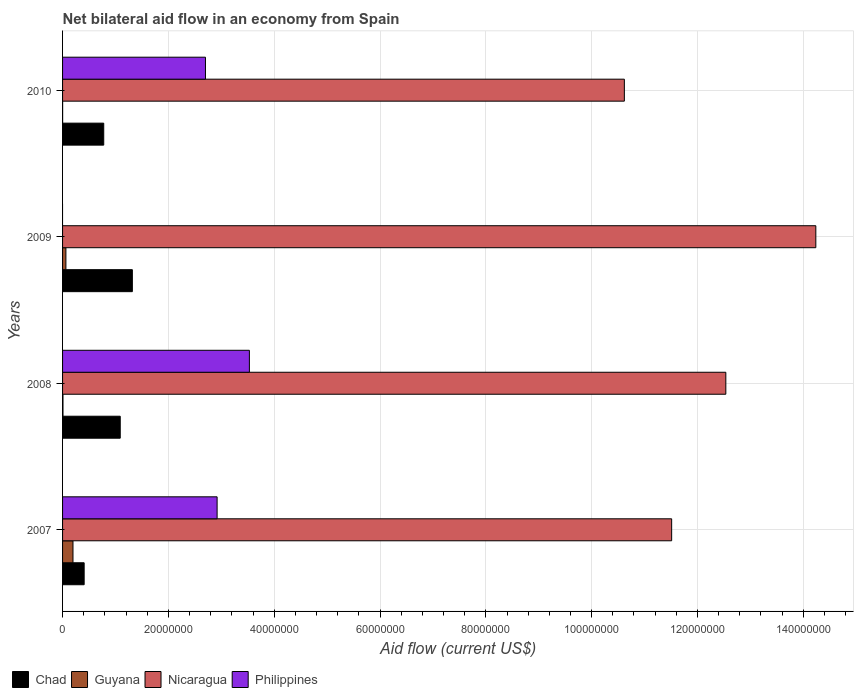How many different coloured bars are there?
Ensure brevity in your answer.  4. Are the number of bars per tick equal to the number of legend labels?
Your answer should be very brief. No. Are the number of bars on each tick of the Y-axis equal?
Offer a very short reply. No. What is the label of the 4th group of bars from the top?
Offer a very short reply. 2007. In how many cases, is the number of bars for a given year not equal to the number of legend labels?
Offer a terse response. 1. What is the net bilateral aid flow in Chad in 2010?
Offer a very short reply. 7.78e+06. Across all years, what is the maximum net bilateral aid flow in Philippines?
Your answer should be compact. 3.53e+07. Across all years, what is the minimum net bilateral aid flow in Guyana?
Make the answer very short. 10000. In which year was the net bilateral aid flow in Philippines maximum?
Provide a short and direct response. 2008. What is the total net bilateral aid flow in Chad in the graph?
Ensure brevity in your answer.  3.60e+07. What is the difference between the net bilateral aid flow in Guyana in 2007 and that in 2010?
Your answer should be very brief. 1.96e+06. What is the average net bilateral aid flow in Chad per year?
Provide a short and direct response. 8.99e+06. In the year 2009, what is the difference between the net bilateral aid flow in Chad and net bilateral aid flow in Guyana?
Your response must be concise. 1.26e+07. What is the ratio of the net bilateral aid flow in Guyana in 2007 to that in 2008?
Your answer should be compact. 24.62. Is the net bilateral aid flow in Chad in 2008 less than that in 2009?
Provide a short and direct response. Yes. Is the difference between the net bilateral aid flow in Chad in 2007 and 2008 greater than the difference between the net bilateral aid flow in Guyana in 2007 and 2008?
Your response must be concise. No. What is the difference between the highest and the second highest net bilateral aid flow in Chad?
Your answer should be compact. 2.29e+06. What is the difference between the highest and the lowest net bilateral aid flow in Guyana?
Make the answer very short. 1.96e+06. In how many years, is the net bilateral aid flow in Philippines greater than the average net bilateral aid flow in Philippines taken over all years?
Offer a terse response. 3. Is the sum of the net bilateral aid flow in Nicaragua in 2007 and 2009 greater than the maximum net bilateral aid flow in Chad across all years?
Offer a very short reply. Yes. How many bars are there?
Keep it short and to the point. 15. What is the difference between two consecutive major ticks on the X-axis?
Provide a short and direct response. 2.00e+07. Are the values on the major ticks of X-axis written in scientific E-notation?
Provide a succinct answer. No. Does the graph contain any zero values?
Give a very brief answer. Yes. Does the graph contain grids?
Your answer should be compact. Yes. Where does the legend appear in the graph?
Provide a succinct answer. Bottom left. How many legend labels are there?
Your answer should be compact. 4. How are the legend labels stacked?
Offer a very short reply. Horizontal. What is the title of the graph?
Offer a terse response. Net bilateral aid flow in an economy from Spain. What is the label or title of the Y-axis?
Keep it short and to the point. Years. What is the Aid flow (current US$) in Chad in 2007?
Make the answer very short. 4.08e+06. What is the Aid flow (current US$) in Guyana in 2007?
Keep it short and to the point. 1.97e+06. What is the Aid flow (current US$) of Nicaragua in 2007?
Your answer should be very brief. 1.15e+08. What is the Aid flow (current US$) in Philippines in 2007?
Provide a short and direct response. 2.92e+07. What is the Aid flow (current US$) of Chad in 2008?
Give a very brief answer. 1.09e+07. What is the Aid flow (current US$) of Guyana in 2008?
Your answer should be very brief. 8.00e+04. What is the Aid flow (current US$) of Nicaragua in 2008?
Provide a short and direct response. 1.25e+08. What is the Aid flow (current US$) of Philippines in 2008?
Provide a short and direct response. 3.53e+07. What is the Aid flow (current US$) of Chad in 2009?
Make the answer very short. 1.32e+07. What is the Aid flow (current US$) in Guyana in 2009?
Your answer should be compact. 6.30e+05. What is the Aid flow (current US$) in Nicaragua in 2009?
Make the answer very short. 1.42e+08. What is the Aid flow (current US$) of Philippines in 2009?
Give a very brief answer. 0. What is the Aid flow (current US$) in Chad in 2010?
Provide a succinct answer. 7.78e+06. What is the Aid flow (current US$) of Nicaragua in 2010?
Make the answer very short. 1.06e+08. What is the Aid flow (current US$) of Philippines in 2010?
Your answer should be very brief. 2.70e+07. Across all years, what is the maximum Aid flow (current US$) of Chad?
Offer a very short reply. 1.32e+07. Across all years, what is the maximum Aid flow (current US$) in Guyana?
Ensure brevity in your answer.  1.97e+06. Across all years, what is the maximum Aid flow (current US$) in Nicaragua?
Your answer should be compact. 1.42e+08. Across all years, what is the maximum Aid flow (current US$) of Philippines?
Offer a terse response. 3.53e+07. Across all years, what is the minimum Aid flow (current US$) in Chad?
Make the answer very short. 4.08e+06. Across all years, what is the minimum Aid flow (current US$) in Nicaragua?
Ensure brevity in your answer.  1.06e+08. Across all years, what is the minimum Aid flow (current US$) in Philippines?
Your answer should be very brief. 0. What is the total Aid flow (current US$) of Chad in the graph?
Your answer should be compact. 3.60e+07. What is the total Aid flow (current US$) in Guyana in the graph?
Give a very brief answer. 2.69e+06. What is the total Aid flow (current US$) of Nicaragua in the graph?
Your answer should be very brief. 4.89e+08. What is the total Aid flow (current US$) of Philippines in the graph?
Offer a very short reply. 9.15e+07. What is the difference between the Aid flow (current US$) in Chad in 2007 and that in 2008?
Keep it short and to the point. -6.82e+06. What is the difference between the Aid flow (current US$) of Guyana in 2007 and that in 2008?
Give a very brief answer. 1.89e+06. What is the difference between the Aid flow (current US$) in Nicaragua in 2007 and that in 2008?
Give a very brief answer. -1.02e+07. What is the difference between the Aid flow (current US$) of Philippines in 2007 and that in 2008?
Offer a very short reply. -6.10e+06. What is the difference between the Aid flow (current US$) in Chad in 2007 and that in 2009?
Your answer should be compact. -9.11e+06. What is the difference between the Aid flow (current US$) of Guyana in 2007 and that in 2009?
Keep it short and to the point. 1.34e+06. What is the difference between the Aid flow (current US$) of Nicaragua in 2007 and that in 2009?
Provide a short and direct response. -2.72e+07. What is the difference between the Aid flow (current US$) in Chad in 2007 and that in 2010?
Make the answer very short. -3.70e+06. What is the difference between the Aid flow (current US$) of Guyana in 2007 and that in 2010?
Make the answer very short. 1.96e+06. What is the difference between the Aid flow (current US$) of Nicaragua in 2007 and that in 2010?
Keep it short and to the point. 8.94e+06. What is the difference between the Aid flow (current US$) of Philippines in 2007 and that in 2010?
Keep it short and to the point. 2.20e+06. What is the difference between the Aid flow (current US$) of Chad in 2008 and that in 2009?
Keep it short and to the point. -2.29e+06. What is the difference between the Aid flow (current US$) in Guyana in 2008 and that in 2009?
Your response must be concise. -5.50e+05. What is the difference between the Aid flow (current US$) in Nicaragua in 2008 and that in 2009?
Offer a terse response. -1.70e+07. What is the difference between the Aid flow (current US$) in Chad in 2008 and that in 2010?
Your answer should be very brief. 3.12e+06. What is the difference between the Aid flow (current US$) in Guyana in 2008 and that in 2010?
Your answer should be compact. 7.00e+04. What is the difference between the Aid flow (current US$) in Nicaragua in 2008 and that in 2010?
Your answer should be very brief. 1.92e+07. What is the difference between the Aid flow (current US$) of Philippines in 2008 and that in 2010?
Your answer should be compact. 8.30e+06. What is the difference between the Aid flow (current US$) of Chad in 2009 and that in 2010?
Make the answer very short. 5.41e+06. What is the difference between the Aid flow (current US$) of Guyana in 2009 and that in 2010?
Give a very brief answer. 6.20e+05. What is the difference between the Aid flow (current US$) in Nicaragua in 2009 and that in 2010?
Offer a terse response. 3.62e+07. What is the difference between the Aid flow (current US$) of Chad in 2007 and the Aid flow (current US$) of Guyana in 2008?
Give a very brief answer. 4.00e+06. What is the difference between the Aid flow (current US$) in Chad in 2007 and the Aid flow (current US$) in Nicaragua in 2008?
Your answer should be very brief. -1.21e+08. What is the difference between the Aid flow (current US$) of Chad in 2007 and the Aid flow (current US$) of Philippines in 2008?
Provide a short and direct response. -3.12e+07. What is the difference between the Aid flow (current US$) in Guyana in 2007 and the Aid flow (current US$) in Nicaragua in 2008?
Offer a very short reply. -1.23e+08. What is the difference between the Aid flow (current US$) in Guyana in 2007 and the Aid flow (current US$) in Philippines in 2008?
Offer a very short reply. -3.33e+07. What is the difference between the Aid flow (current US$) of Nicaragua in 2007 and the Aid flow (current US$) of Philippines in 2008?
Provide a short and direct response. 7.98e+07. What is the difference between the Aid flow (current US$) in Chad in 2007 and the Aid flow (current US$) in Guyana in 2009?
Offer a very short reply. 3.45e+06. What is the difference between the Aid flow (current US$) in Chad in 2007 and the Aid flow (current US$) in Nicaragua in 2009?
Keep it short and to the point. -1.38e+08. What is the difference between the Aid flow (current US$) in Guyana in 2007 and the Aid flow (current US$) in Nicaragua in 2009?
Provide a succinct answer. -1.40e+08. What is the difference between the Aid flow (current US$) of Chad in 2007 and the Aid flow (current US$) of Guyana in 2010?
Provide a short and direct response. 4.07e+06. What is the difference between the Aid flow (current US$) of Chad in 2007 and the Aid flow (current US$) of Nicaragua in 2010?
Your response must be concise. -1.02e+08. What is the difference between the Aid flow (current US$) in Chad in 2007 and the Aid flow (current US$) in Philippines in 2010?
Offer a terse response. -2.29e+07. What is the difference between the Aid flow (current US$) of Guyana in 2007 and the Aid flow (current US$) of Nicaragua in 2010?
Make the answer very short. -1.04e+08. What is the difference between the Aid flow (current US$) of Guyana in 2007 and the Aid flow (current US$) of Philippines in 2010?
Provide a short and direct response. -2.50e+07. What is the difference between the Aid flow (current US$) of Nicaragua in 2007 and the Aid flow (current US$) of Philippines in 2010?
Your response must be concise. 8.81e+07. What is the difference between the Aid flow (current US$) of Chad in 2008 and the Aid flow (current US$) of Guyana in 2009?
Provide a succinct answer. 1.03e+07. What is the difference between the Aid flow (current US$) of Chad in 2008 and the Aid flow (current US$) of Nicaragua in 2009?
Ensure brevity in your answer.  -1.31e+08. What is the difference between the Aid flow (current US$) in Guyana in 2008 and the Aid flow (current US$) in Nicaragua in 2009?
Your answer should be compact. -1.42e+08. What is the difference between the Aid flow (current US$) in Chad in 2008 and the Aid flow (current US$) in Guyana in 2010?
Give a very brief answer. 1.09e+07. What is the difference between the Aid flow (current US$) in Chad in 2008 and the Aid flow (current US$) in Nicaragua in 2010?
Offer a very short reply. -9.53e+07. What is the difference between the Aid flow (current US$) in Chad in 2008 and the Aid flow (current US$) in Philippines in 2010?
Provide a short and direct response. -1.61e+07. What is the difference between the Aid flow (current US$) of Guyana in 2008 and the Aid flow (current US$) of Nicaragua in 2010?
Your response must be concise. -1.06e+08. What is the difference between the Aid flow (current US$) of Guyana in 2008 and the Aid flow (current US$) of Philippines in 2010?
Provide a short and direct response. -2.69e+07. What is the difference between the Aid flow (current US$) in Nicaragua in 2008 and the Aid flow (current US$) in Philippines in 2010?
Offer a very short reply. 9.84e+07. What is the difference between the Aid flow (current US$) of Chad in 2009 and the Aid flow (current US$) of Guyana in 2010?
Your answer should be very brief. 1.32e+07. What is the difference between the Aid flow (current US$) of Chad in 2009 and the Aid flow (current US$) of Nicaragua in 2010?
Give a very brief answer. -9.30e+07. What is the difference between the Aid flow (current US$) of Chad in 2009 and the Aid flow (current US$) of Philippines in 2010?
Give a very brief answer. -1.38e+07. What is the difference between the Aid flow (current US$) of Guyana in 2009 and the Aid flow (current US$) of Nicaragua in 2010?
Make the answer very short. -1.06e+08. What is the difference between the Aid flow (current US$) of Guyana in 2009 and the Aid flow (current US$) of Philippines in 2010?
Keep it short and to the point. -2.64e+07. What is the difference between the Aid flow (current US$) of Nicaragua in 2009 and the Aid flow (current US$) of Philippines in 2010?
Provide a short and direct response. 1.15e+08. What is the average Aid flow (current US$) of Chad per year?
Offer a terse response. 8.99e+06. What is the average Aid flow (current US$) of Guyana per year?
Keep it short and to the point. 6.72e+05. What is the average Aid flow (current US$) of Nicaragua per year?
Give a very brief answer. 1.22e+08. What is the average Aid flow (current US$) of Philippines per year?
Keep it short and to the point. 2.29e+07. In the year 2007, what is the difference between the Aid flow (current US$) in Chad and Aid flow (current US$) in Guyana?
Provide a succinct answer. 2.11e+06. In the year 2007, what is the difference between the Aid flow (current US$) of Chad and Aid flow (current US$) of Nicaragua?
Offer a terse response. -1.11e+08. In the year 2007, what is the difference between the Aid flow (current US$) of Chad and Aid flow (current US$) of Philippines?
Make the answer very short. -2.51e+07. In the year 2007, what is the difference between the Aid flow (current US$) in Guyana and Aid flow (current US$) in Nicaragua?
Your answer should be very brief. -1.13e+08. In the year 2007, what is the difference between the Aid flow (current US$) of Guyana and Aid flow (current US$) of Philippines?
Keep it short and to the point. -2.72e+07. In the year 2007, what is the difference between the Aid flow (current US$) in Nicaragua and Aid flow (current US$) in Philippines?
Offer a terse response. 8.59e+07. In the year 2008, what is the difference between the Aid flow (current US$) in Chad and Aid flow (current US$) in Guyana?
Your answer should be very brief. 1.08e+07. In the year 2008, what is the difference between the Aid flow (current US$) of Chad and Aid flow (current US$) of Nicaragua?
Give a very brief answer. -1.14e+08. In the year 2008, what is the difference between the Aid flow (current US$) of Chad and Aid flow (current US$) of Philippines?
Your answer should be compact. -2.44e+07. In the year 2008, what is the difference between the Aid flow (current US$) of Guyana and Aid flow (current US$) of Nicaragua?
Give a very brief answer. -1.25e+08. In the year 2008, what is the difference between the Aid flow (current US$) in Guyana and Aid flow (current US$) in Philippines?
Give a very brief answer. -3.52e+07. In the year 2008, what is the difference between the Aid flow (current US$) of Nicaragua and Aid flow (current US$) of Philippines?
Your answer should be very brief. 9.00e+07. In the year 2009, what is the difference between the Aid flow (current US$) in Chad and Aid flow (current US$) in Guyana?
Your answer should be very brief. 1.26e+07. In the year 2009, what is the difference between the Aid flow (current US$) in Chad and Aid flow (current US$) in Nicaragua?
Your answer should be compact. -1.29e+08. In the year 2009, what is the difference between the Aid flow (current US$) of Guyana and Aid flow (current US$) of Nicaragua?
Your response must be concise. -1.42e+08. In the year 2010, what is the difference between the Aid flow (current US$) of Chad and Aid flow (current US$) of Guyana?
Give a very brief answer. 7.77e+06. In the year 2010, what is the difference between the Aid flow (current US$) in Chad and Aid flow (current US$) in Nicaragua?
Your answer should be compact. -9.84e+07. In the year 2010, what is the difference between the Aid flow (current US$) of Chad and Aid flow (current US$) of Philippines?
Give a very brief answer. -1.92e+07. In the year 2010, what is the difference between the Aid flow (current US$) of Guyana and Aid flow (current US$) of Nicaragua?
Keep it short and to the point. -1.06e+08. In the year 2010, what is the difference between the Aid flow (current US$) of Guyana and Aid flow (current US$) of Philippines?
Keep it short and to the point. -2.70e+07. In the year 2010, what is the difference between the Aid flow (current US$) in Nicaragua and Aid flow (current US$) in Philippines?
Your answer should be compact. 7.92e+07. What is the ratio of the Aid flow (current US$) in Chad in 2007 to that in 2008?
Offer a terse response. 0.37. What is the ratio of the Aid flow (current US$) of Guyana in 2007 to that in 2008?
Provide a short and direct response. 24.62. What is the ratio of the Aid flow (current US$) in Nicaragua in 2007 to that in 2008?
Provide a succinct answer. 0.92. What is the ratio of the Aid flow (current US$) of Philippines in 2007 to that in 2008?
Offer a terse response. 0.83. What is the ratio of the Aid flow (current US$) of Chad in 2007 to that in 2009?
Your answer should be compact. 0.31. What is the ratio of the Aid flow (current US$) of Guyana in 2007 to that in 2009?
Your answer should be very brief. 3.13. What is the ratio of the Aid flow (current US$) of Nicaragua in 2007 to that in 2009?
Provide a short and direct response. 0.81. What is the ratio of the Aid flow (current US$) in Chad in 2007 to that in 2010?
Give a very brief answer. 0.52. What is the ratio of the Aid flow (current US$) of Guyana in 2007 to that in 2010?
Ensure brevity in your answer.  197. What is the ratio of the Aid flow (current US$) in Nicaragua in 2007 to that in 2010?
Offer a very short reply. 1.08. What is the ratio of the Aid flow (current US$) in Philippines in 2007 to that in 2010?
Provide a succinct answer. 1.08. What is the ratio of the Aid flow (current US$) in Chad in 2008 to that in 2009?
Give a very brief answer. 0.83. What is the ratio of the Aid flow (current US$) in Guyana in 2008 to that in 2009?
Offer a terse response. 0.13. What is the ratio of the Aid flow (current US$) of Nicaragua in 2008 to that in 2009?
Give a very brief answer. 0.88. What is the ratio of the Aid flow (current US$) of Chad in 2008 to that in 2010?
Ensure brevity in your answer.  1.4. What is the ratio of the Aid flow (current US$) of Nicaragua in 2008 to that in 2010?
Your answer should be very brief. 1.18. What is the ratio of the Aid flow (current US$) of Philippines in 2008 to that in 2010?
Your response must be concise. 1.31. What is the ratio of the Aid flow (current US$) in Chad in 2009 to that in 2010?
Your response must be concise. 1.7. What is the ratio of the Aid flow (current US$) in Guyana in 2009 to that in 2010?
Offer a very short reply. 63. What is the ratio of the Aid flow (current US$) in Nicaragua in 2009 to that in 2010?
Offer a very short reply. 1.34. What is the difference between the highest and the second highest Aid flow (current US$) of Chad?
Give a very brief answer. 2.29e+06. What is the difference between the highest and the second highest Aid flow (current US$) of Guyana?
Your answer should be compact. 1.34e+06. What is the difference between the highest and the second highest Aid flow (current US$) in Nicaragua?
Keep it short and to the point. 1.70e+07. What is the difference between the highest and the second highest Aid flow (current US$) of Philippines?
Your answer should be very brief. 6.10e+06. What is the difference between the highest and the lowest Aid flow (current US$) in Chad?
Make the answer very short. 9.11e+06. What is the difference between the highest and the lowest Aid flow (current US$) of Guyana?
Keep it short and to the point. 1.96e+06. What is the difference between the highest and the lowest Aid flow (current US$) of Nicaragua?
Offer a terse response. 3.62e+07. What is the difference between the highest and the lowest Aid flow (current US$) in Philippines?
Offer a very short reply. 3.53e+07. 